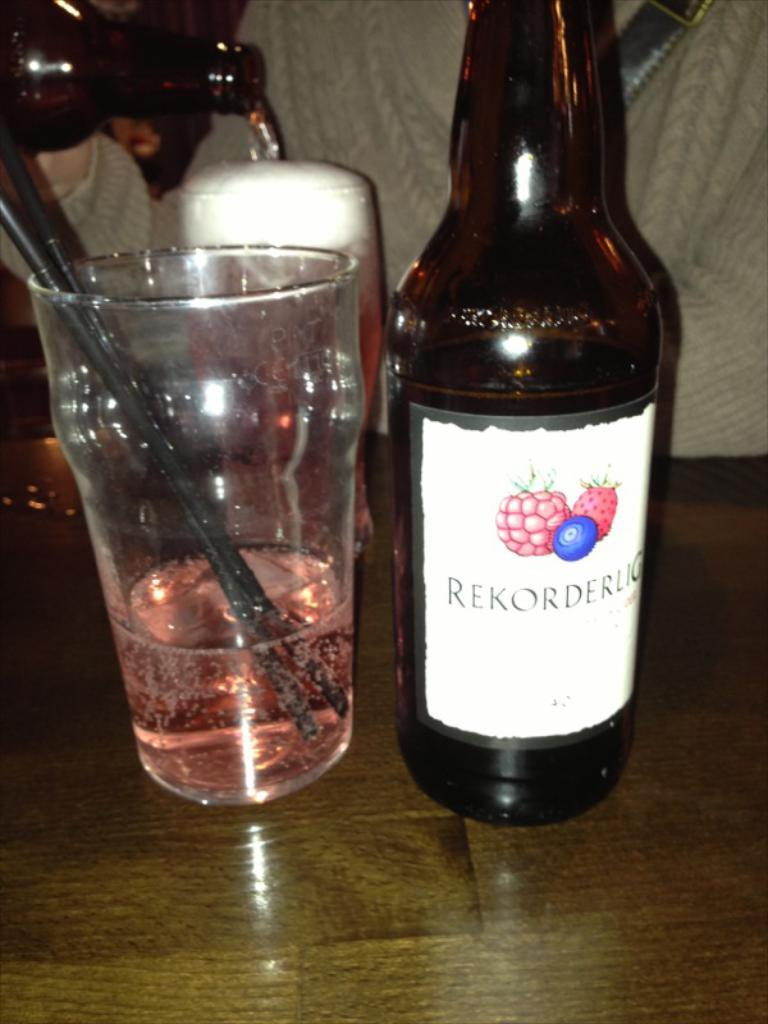<image>
Describe the image concisely. A nearly empty glass, with two small straws sticking out, is on a table next to a bottle of Rekorderlig. 